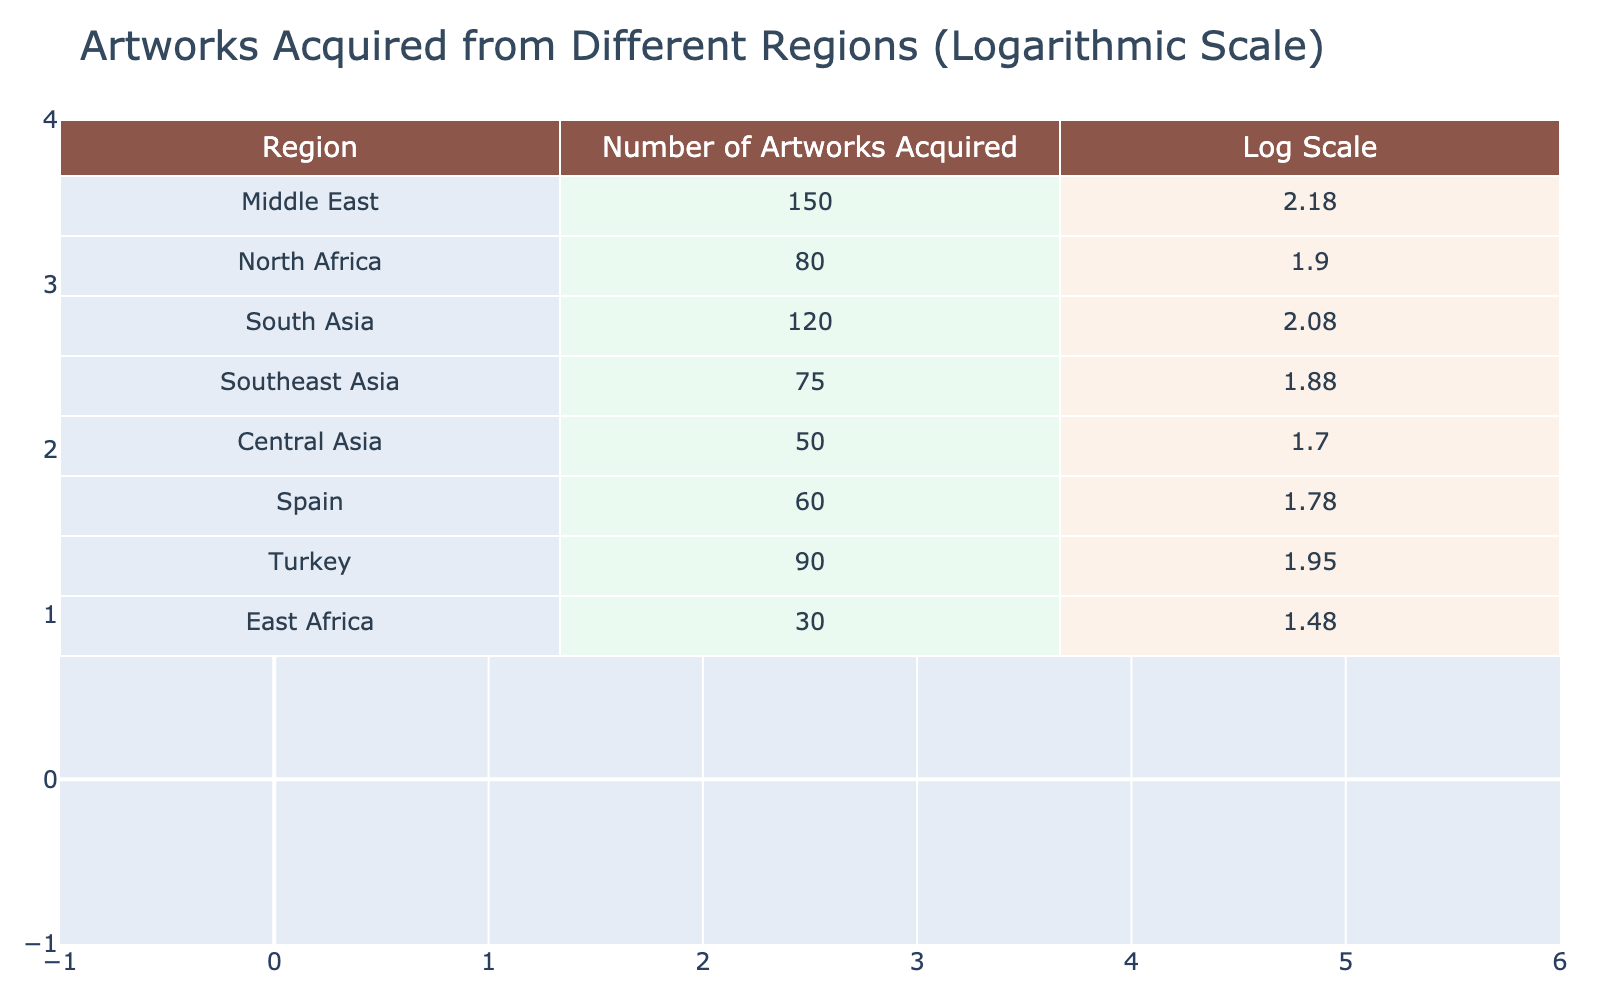What region acquired the most artworks? By evaluating the "Number of Artworks Acquired" column, I can see that the Middle East has the highest value at 150.
Answer: Middle East What is the total number of artworks acquired from Southeast Asia and East Africa? The number of artworks from Southeast Asia is 75, and from East Africa is 30. Adding these two values gives 75 + 30 = 105.
Answer: 105 Is the number of artworks acquired from North Africa greater than those from Central Asia? North Africa has 80 artworks, while Central Asia has 50. Since 80 is greater than 50, the answer is yes.
Answer: Yes What is the logarithmic value of the number of artworks acquired from Turkey? The table shows that Turkey has 90 artworks. The logarithmic value of 90 calculated is approximately 1.95.
Answer: 1.95 Which two regions acquired the least number of artworks combined? East Africa acquired 30 artworks, and Central Asia acquired 50. The sum of these values is 30 + 50 = 80, which represents the least combined total.
Answer: East Africa and Central Asia What is the average number of artworks acquired from the regions listed? First, I add all the artworks: 150 + 80 + 120 + 75 + 50 + 60 + 90 + 30 = 705. There are 8 regions, so the average is 705 / 8 = 88.125.
Answer: 88.125 Did any region acquire more than 100 artworks? Only the Middle East with 150 and South Asia with 120 acquired over 100 artworks. Thus, the answer is yes.
Answer: Yes Which region had a logarithmic value closest to 1? The table indicates the following logarithmic values: Middle East (2.18), North Africa (1.90), South Asia (2.08), Southeast Asia (1.88), Central Asia (1.70), Spain (1.78), Turkey (1.95), and East Africa (1.48). The closest to 1 is East Africa at approximately 1.48.
Answer: East Africa 